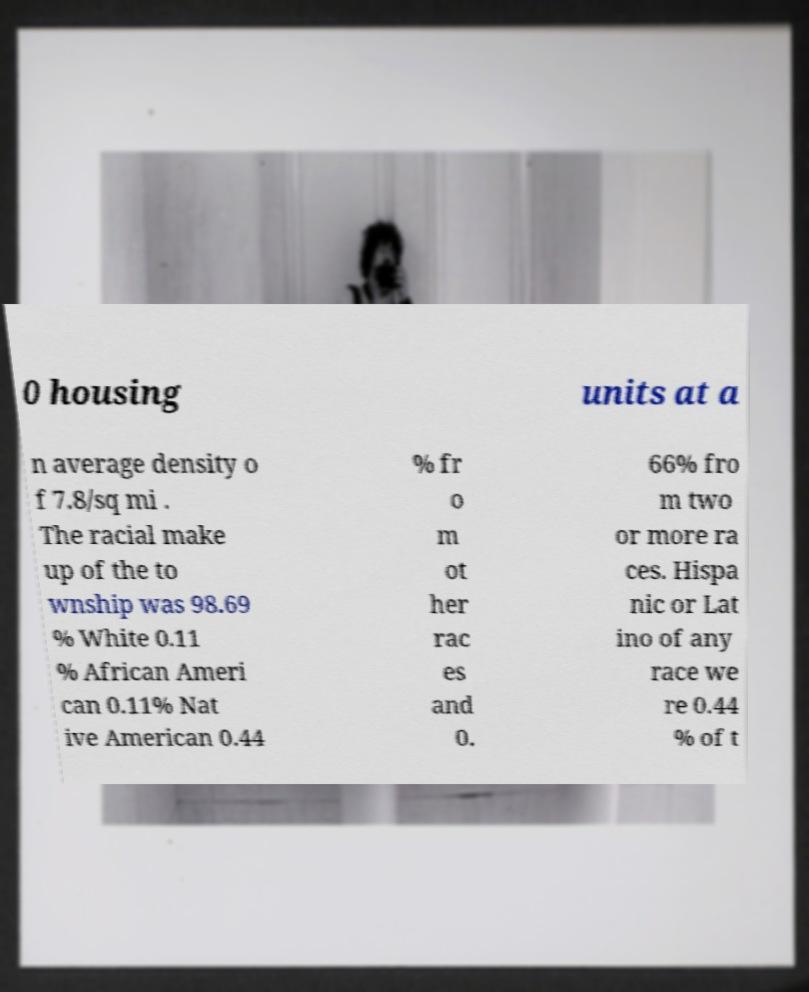Could you assist in decoding the text presented in this image and type it out clearly? 0 housing units at a n average density o f 7.8/sq mi . The racial make up of the to wnship was 98.69 % White 0.11 % African Ameri can 0.11% Nat ive American 0.44 % fr o m ot her rac es and 0. 66% fro m two or more ra ces. Hispa nic or Lat ino of any race we re 0.44 % of t 